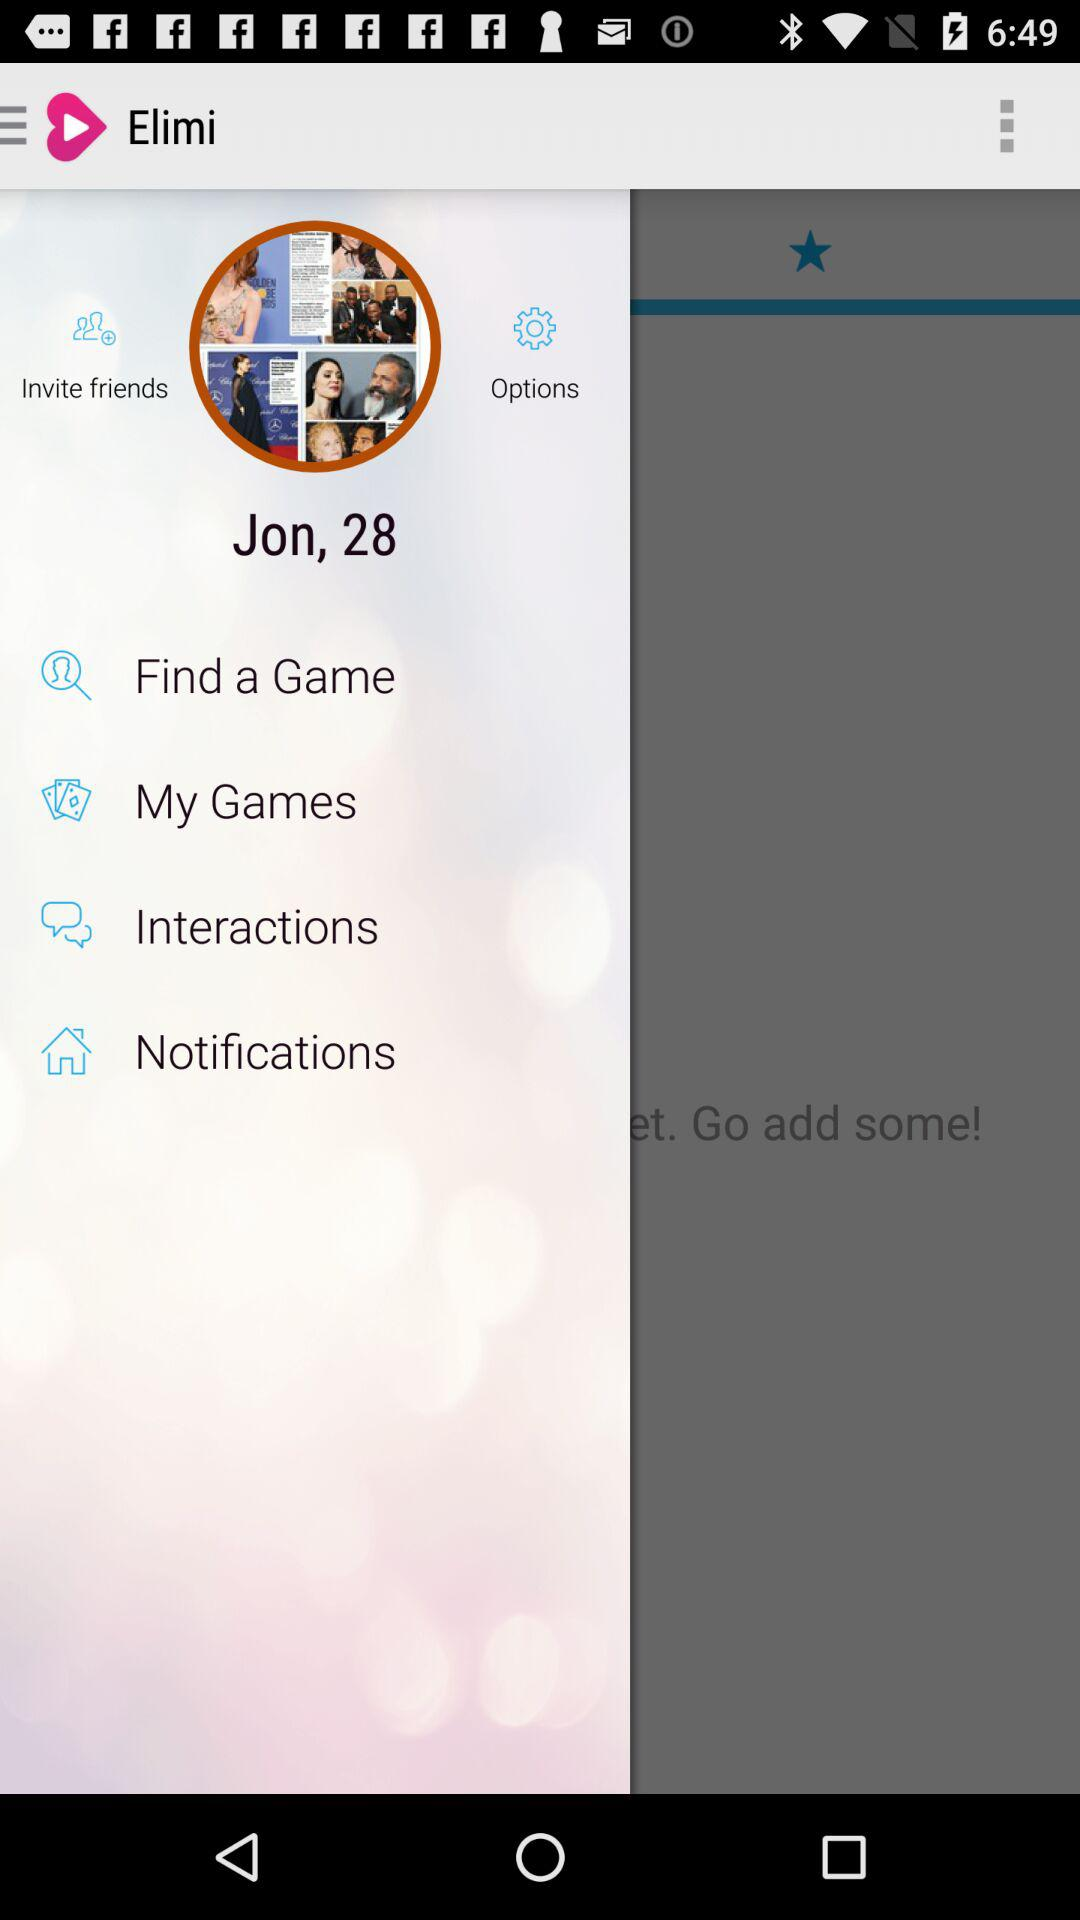What is the age? The age is 28 years old. 